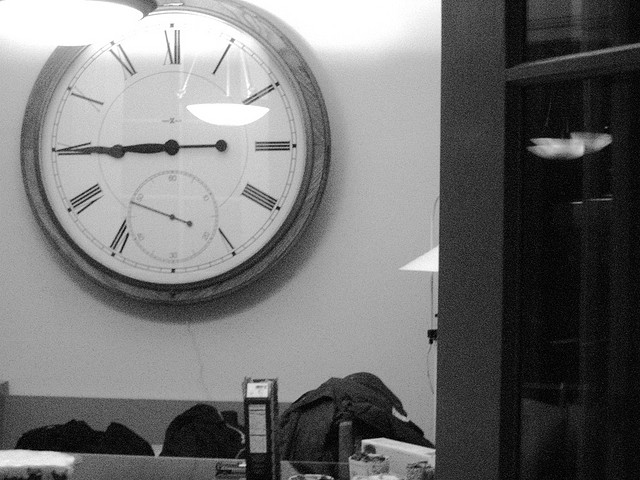Please extract the text content from this image. XII V X I II 50 40 30 20 10 60 VI VIII VII V IIII III 